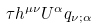<formula> <loc_0><loc_0><loc_500><loc_500>\tau h ^ { \mu \nu } U ^ { \alpha } q _ { \nu ; \alpha }</formula> 